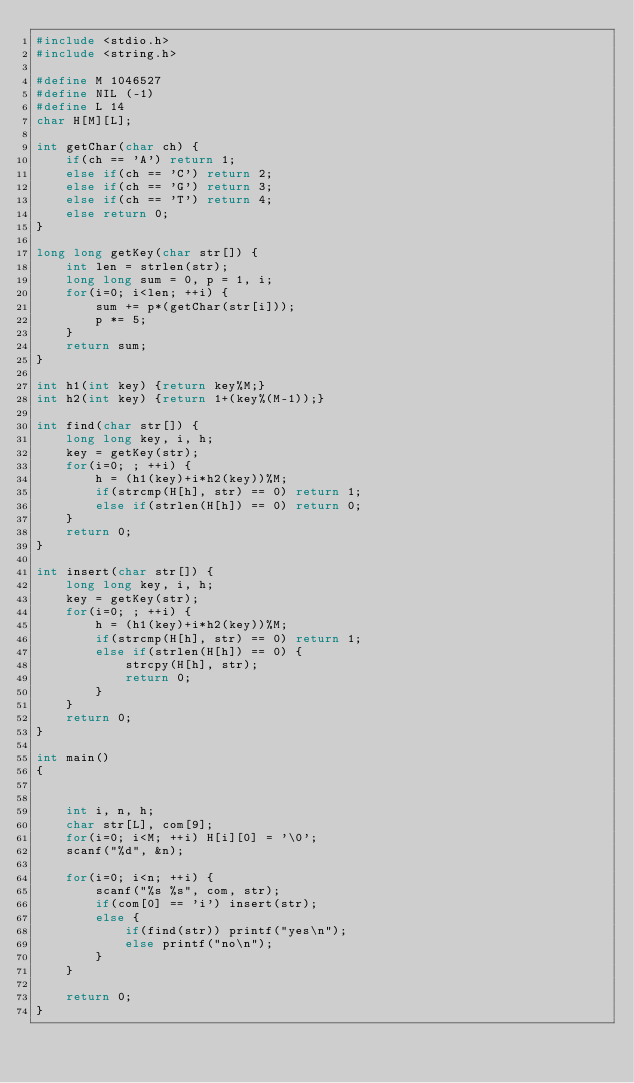Convert code to text. <code><loc_0><loc_0><loc_500><loc_500><_C_>#include <stdio.h>
#include <string.h>

#define M 1046527
#define NIL (-1)
#define L 14
char H[M][L];

int getChar(char ch) {
    if(ch == 'A') return 1;
    else if(ch == 'C') return 2;
    else if(ch == 'G') return 3;
    else if(ch == 'T') return 4;
    else return 0;
}

long long getKey(char str[]) {
    int len = strlen(str);
    long long sum = 0, p = 1, i;
    for(i=0; i<len; ++i) {
        sum += p*(getChar(str[i]));
        p *= 5;
    }
    return sum;
}

int h1(int key) {return key%M;}
int h2(int key) {return 1+(key%(M-1));}

int find(char str[]) {
    long long key, i, h;
    key = getKey(str);
    for(i=0; ; ++i) {
        h = (h1(key)+i*h2(key))%M;
        if(strcmp(H[h], str) == 0) return 1;
        else if(strlen(H[h]) == 0) return 0;
    }
    return 0;
}

int insert(char str[]) {
    long long key, i, h;
    key = getKey(str);
    for(i=0; ; ++i) {
        h = (h1(key)+i*h2(key))%M;
        if(strcmp(H[h], str) == 0) return 1;
        else if(strlen(H[h]) == 0) {
            strcpy(H[h], str);
            return 0;
        }
    }
    return 0;
}

int main()
{
     

    int i, n, h;
    char str[L], com[9];
    for(i=0; i<M; ++i) H[i][0] = '\0';
    scanf("%d", &n);
    
    for(i=0; i<n; ++i) {
        scanf("%s %s", com, str);
        if(com[0] == 'i') insert(str);
        else {
            if(find(str)) printf("yes\n");
            else printf("no\n");
        }
    }

    return 0;
}
</code> 